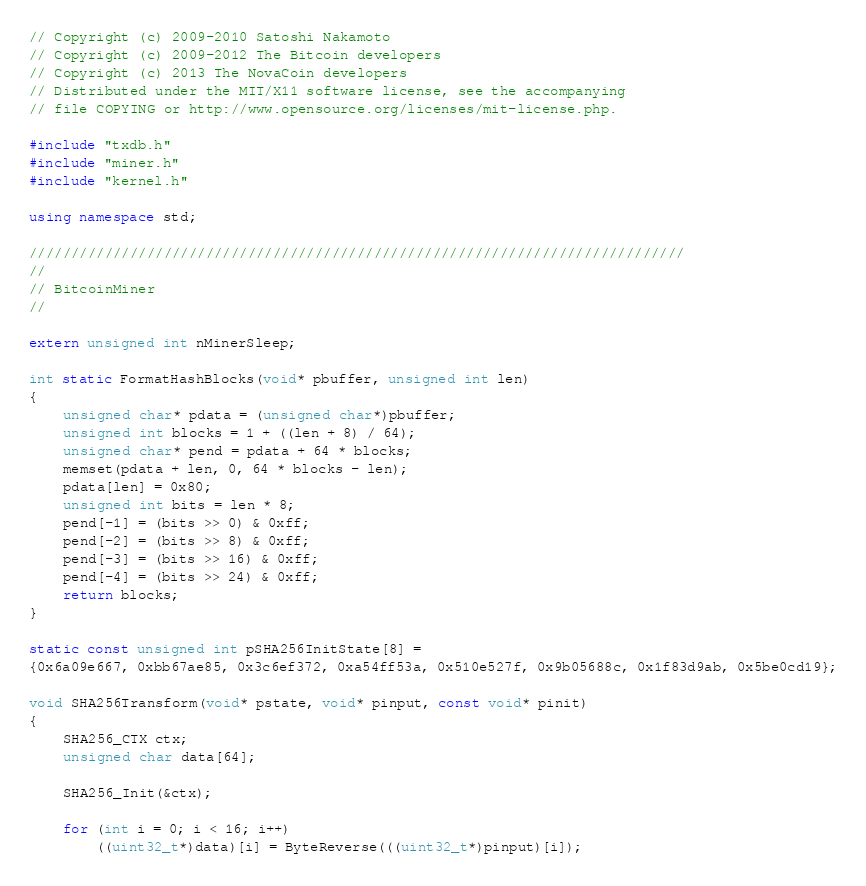<code> <loc_0><loc_0><loc_500><loc_500><_C++_>// Copyright (c) 2009-2010 Satoshi Nakamoto
// Copyright (c) 2009-2012 The Bitcoin developers
// Copyright (c) 2013 The NovaCoin developers
// Distributed under the MIT/X11 software license, see the accompanying
// file COPYING or http://www.opensource.org/licenses/mit-license.php.

#include "txdb.h"
#include "miner.h"
#include "kernel.h"

using namespace std;

//////////////////////////////////////////////////////////////////////////////
//
// BitcoinMiner
//

extern unsigned int nMinerSleep;

int static FormatHashBlocks(void* pbuffer, unsigned int len)
{
    unsigned char* pdata = (unsigned char*)pbuffer;
    unsigned int blocks = 1 + ((len + 8) / 64);
    unsigned char* pend = pdata + 64 * blocks;
    memset(pdata + len, 0, 64 * blocks - len);
    pdata[len] = 0x80;
    unsigned int bits = len * 8;
    pend[-1] = (bits >> 0) & 0xff;
    pend[-2] = (bits >> 8) & 0xff;
    pend[-3] = (bits >> 16) & 0xff;
    pend[-4] = (bits >> 24) & 0xff;
    return blocks;
}

static const unsigned int pSHA256InitState[8] =
{0x6a09e667, 0xbb67ae85, 0x3c6ef372, 0xa54ff53a, 0x510e527f, 0x9b05688c, 0x1f83d9ab, 0x5be0cd19};

void SHA256Transform(void* pstate, void* pinput, const void* pinit)
{
    SHA256_CTX ctx;
    unsigned char data[64];

    SHA256_Init(&ctx);

    for (int i = 0; i < 16; i++)
        ((uint32_t*)data)[i] = ByteReverse(((uint32_t*)pinput)[i]);
</code> 